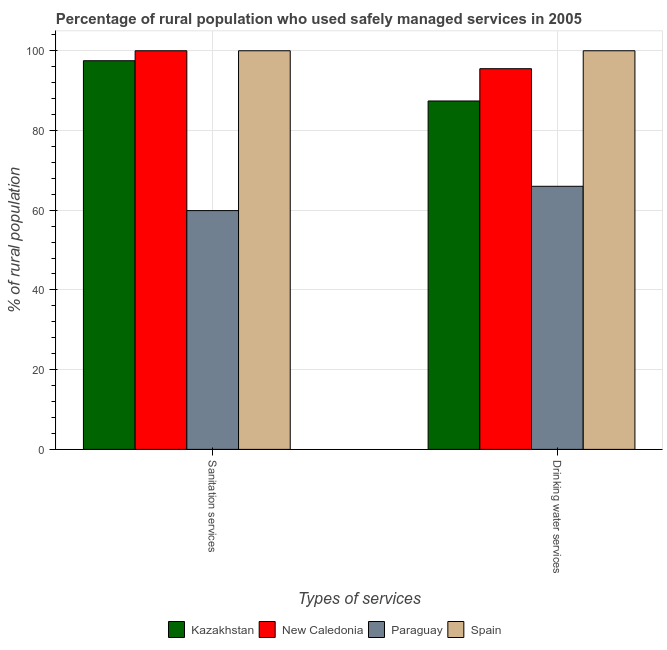How many different coloured bars are there?
Make the answer very short. 4. Are the number of bars on each tick of the X-axis equal?
Provide a short and direct response. Yes. What is the label of the 1st group of bars from the left?
Your answer should be compact. Sanitation services. Across all countries, what is the maximum percentage of rural population who used sanitation services?
Provide a short and direct response. 100. Across all countries, what is the minimum percentage of rural population who used sanitation services?
Offer a terse response. 59.9. In which country was the percentage of rural population who used sanitation services maximum?
Your answer should be compact. New Caledonia. In which country was the percentage of rural population who used sanitation services minimum?
Your answer should be compact. Paraguay. What is the total percentage of rural population who used sanitation services in the graph?
Offer a terse response. 357.4. What is the difference between the percentage of rural population who used sanitation services in New Caledonia and that in Kazakhstan?
Ensure brevity in your answer.  2.5. What is the difference between the percentage of rural population who used drinking water services in Spain and the percentage of rural population who used sanitation services in Paraguay?
Ensure brevity in your answer.  40.1. What is the average percentage of rural population who used sanitation services per country?
Provide a succinct answer. 89.35. What is the ratio of the percentage of rural population who used sanitation services in Paraguay to that in Spain?
Offer a very short reply. 0.6. In how many countries, is the percentage of rural population who used sanitation services greater than the average percentage of rural population who used sanitation services taken over all countries?
Offer a terse response. 3. What does the 1st bar from the left in Drinking water services represents?
Offer a very short reply. Kazakhstan. What does the 3rd bar from the right in Drinking water services represents?
Your answer should be very brief. New Caledonia. Are all the bars in the graph horizontal?
Provide a succinct answer. No. How many countries are there in the graph?
Keep it short and to the point. 4. What is the difference between two consecutive major ticks on the Y-axis?
Offer a terse response. 20. Are the values on the major ticks of Y-axis written in scientific E-notation?
Provide a short and direct response. No. Does the graph contain any zero values?
Your response must be concise. No. Where does the legend appear in the graph?
Your answer should be very brief. Bottom center. What is the title of the graph?
Keep it short and to the point. Percentage of rural population who used safely managed services in 2005. What is the label or title of the X-axis?
Keep it short and to the point. Types of services. What is the label or title of the Y-axis?
Offer a very short reply. % of rural population. What is the % of rural population of Kazakhstan in Sanitation services?
Provide a succinct answer. 97.5. What is the % of rural population in New Caledonia in Sanitation services?
Your answer should be very brief. 100. What is the % of rural population of Paraguay in Sanitation services?
Your answer should be compact. 59.9. What is the % of rural population in Spain in Sanitation services?
Ensure brevity in your answer.  100. What is the % of rural population in Kazakhstan in Drinking water services?
Keep it short and to the point. 87.4. What is the % of rural population in New Caledonia in Drinking water services?
Make the answer very short. 95.5. Across all Types of services, what is the maximum % of rural population in Kazakhstan?
Provide a short and direct response. 97.5. Across all Types of services, what is the maximum % of rural population of New Caledonia?
Your answer should be compact. 100. Across all Types of services, what is the minimum % of rural population of Kazakhstan?
Your answer should be very brief. 87.4. Across all Types of services, what is the minimum % of rural population of New Caledonia?
Offer a very short reply. 95.5. Across all Types of services, what is the minimum % of rural population in Paraguay?
Ensure brevity in your answer.  59.9. Across all Types of services, what is the minimum % of rural population in Spain?
Make the answer very short. 100. What is the total % of rural population of Kazakhstan in the graph?
Your answer should be very brief. 184.9. What is the total % of rural population of New Caledonia in the graph?
Ensure brevity in your answer.  195.5. What is the total % of rural population of Paraguay in the graph?
Offer a very short reply. 125.9. What is the total % of rural population of Spain in the graph?
Keep it short and to the point. 200. What is the difference between the % of rural population in New Caledonia in Sanitation services and that in Drinking water services?
Provide a short and direct response. 4.5. What is the difference between the % of rural population of Spain in Sanitation services and that in Drinking water services?
Ensure brevity in your answer.  0. What is the difference between the % of rural population of Kazakhstan in Sanitation services and the % of rural population of New Caledonia in Drinking water services?
Keep it short and to the point. 2. What is the difference between the % of rural population in Kazakhstan in Sanitation services and the % of rural population in Paraguay in Drinking water services?
Offer a very short reply. 31.5. What is the difference between the % of rural population of New Caledonia in Sanitation services and the % of rural population of Paraguay in Drinking water services?
Your answer should be very brief. 34. What is the difference between the % of rural population in Paraguay in Sanitation services and the % of rural population in Spain in Drinking water services?
Give a very brief answer. -40.1. What is the average % of rural population in Kazakhstan per Types of services?
Keep it short and to the point. 92.45. What is the average % of rural population of New Caledonia per Types of services?
Offer a very short reply. 97.75. What is the average % of rural population of Paraguay per Types of services?
Give a very brief answer. 62.95. What is the difference between the % of rural population of Kazakhstan and % of rural population of New Caledonia in Sanitation services?
Offer a terse response. -2.5. What is the difference between the % of rural population of Kazakhstan and % of rural population of Paraguay in Sanitation services?
Offer a very short reply. 37.6. What is the difference between the % of rural population in Kazakhstan and % of rural population in Spain in Sanitation services?
Provide a succinct answer. -2.5. What is the difference between the % of rural population in New Caledonia and % of rural population in Paraguay in Sanitation services?
Provide a short and direct response. 40.1. What is the difference between the % of rural population of Paraguay and % of rural population of Spain in Sanitation services?
Give a very brief answer. -40.1. What is the difference between the % of rural population of Kazakhstan and % of rural population of Paraguay in Drinking water services?
Make the answer very short. 21.4. What is the difference between the % of rural population in Kazakhstan and % of rural population in Spain in Drinking water services?
Provide a succinct answer. -12.6. What is the difference between the % of rural population of New Caledonia and % of rural population of Paraguay in Drinking water services?
Provide a short and direct response. 29.5. What is the difference between the % of rural population in New Caledonia and % of rural population in Spain in Drinking water services?
Offer a terse response. -4.5. What is the difference between the % of rural population of Paraguay and % of rural population of Spain in Drinking water services?
Your answer should be very brief. -34. What is the ratio of the % of rural population of Kazakhstan in Sanitation services to that in Drinking water services?
Offer a very short reply. 1.12. What is the ratio of the % of rural population in New Caledonia in Sanitation services to that in Drinking water services?
Your answer should be very brief. 1.05. What is the ratio of the % of rural population in Paraguay in Sanitation services to that in Drinking water services?
Provide a succinct answer. 0.91. What is the ratio of the % of rural population in Spain in Sanitation services to that in Drinking water services?
Your response must be concise. 1. What is the difference between the highest and the second highest % of rural population of New Caledonia?
Offer a very short reply. 4.5. What is the difference between the highest and the second highest % of rural population of Paraguay?
Make the answer very short. 6.1. What is the difference between the highest and the second highest % of rural population of Spain?
Your response must be concise. 0. What is the difference between the highest and the lowest % of rural population of Kazakhstan?
Your answer should be very brief. 10.1. What is the difference between the highest and the lowest % of rural population in Paraguay?
Your answer should be very brief. 6.1. What is the difference between the highest and the lowest % of rural population of Spain?
Make the answer very short. 0. 